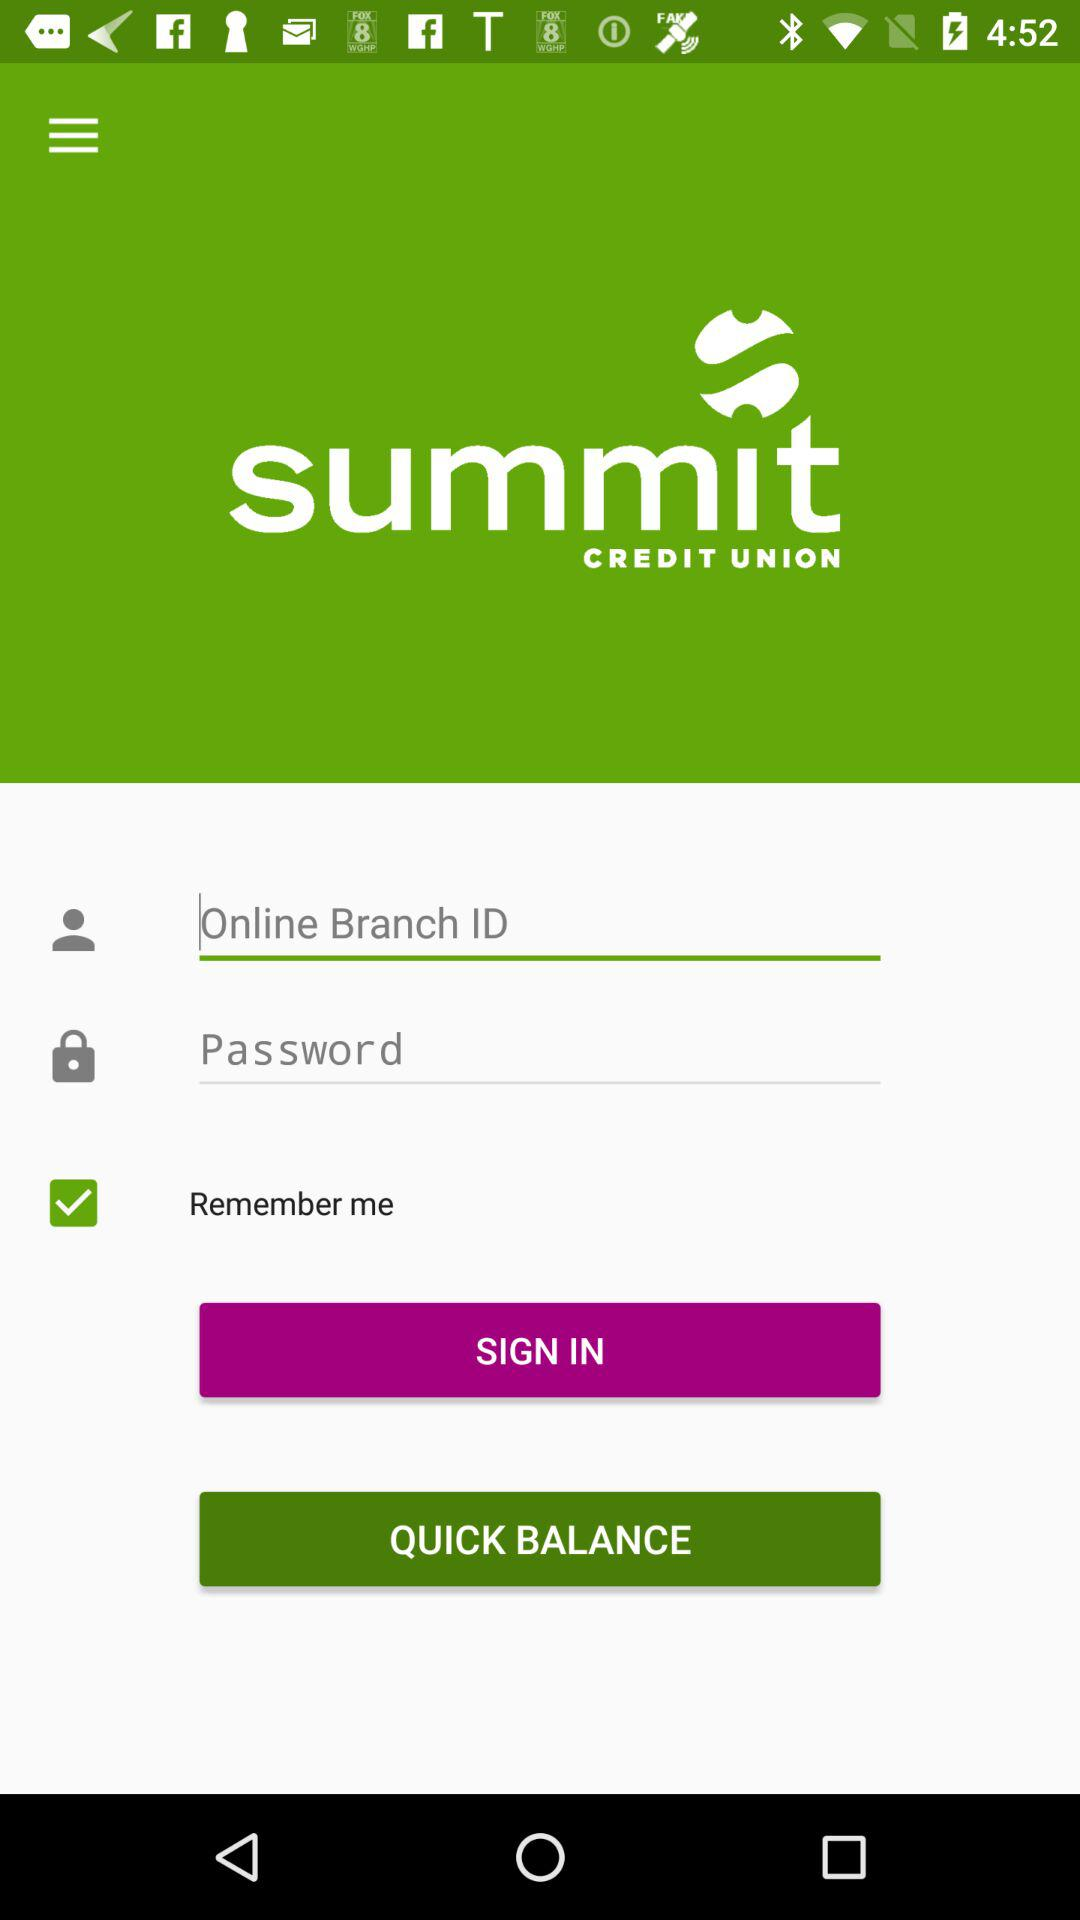What is the status of "Remember me"? The status is "on". 